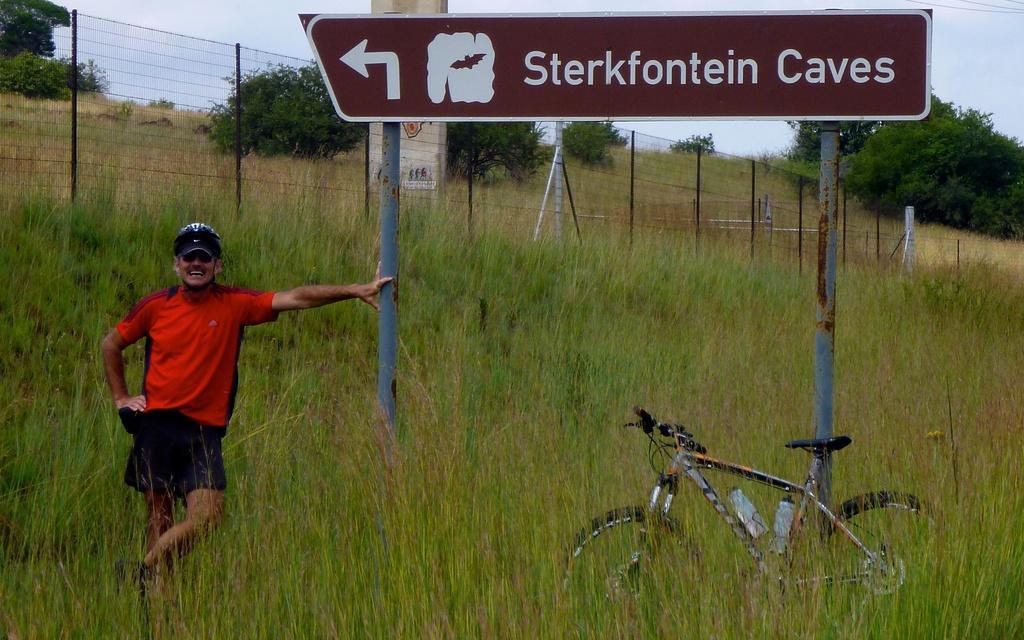Please provide a concise description of this image. The picture is taken outside a city. In the foreground of the picture there arch plants, grass, bicycle, a person and a sign board. In the center of the picture there is fencing, outside the fencing the trees, plants and a pole. Sky is cloudy. On the top right there cables. 